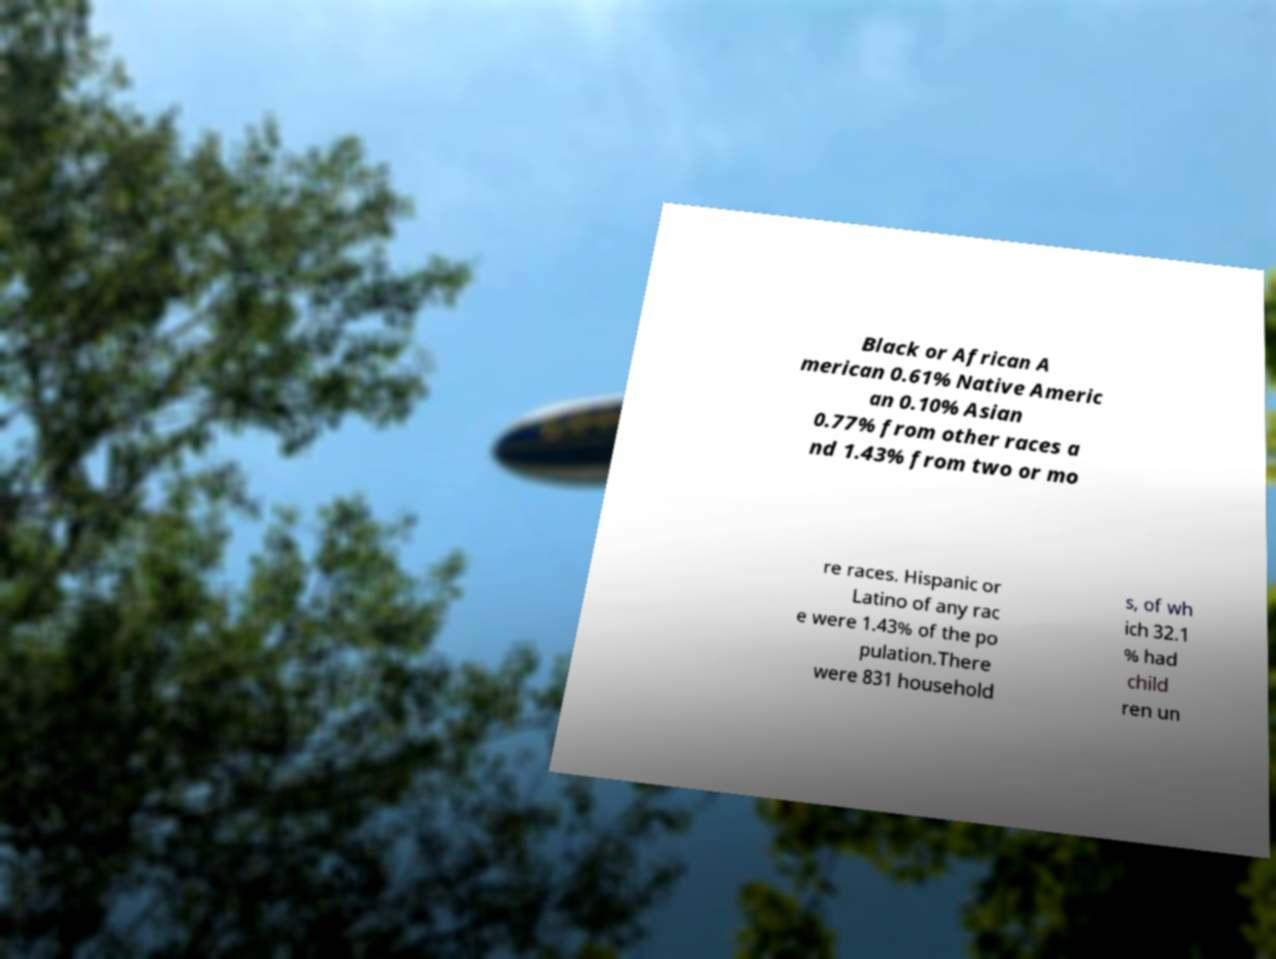Can you read and provide the text displayed in the image?This photo seems to have some interesting text. Can you extract and type it out for me? Black or African A merican 0.61% Native Americ an 0.10% Asian 0.77% from other races a nd 1.43% from two or mo re races. Hispanic or Latino of any rac e were 1.43% of the po pulation.There were 831 household s, of wh ich 32.1 % had child ren un 